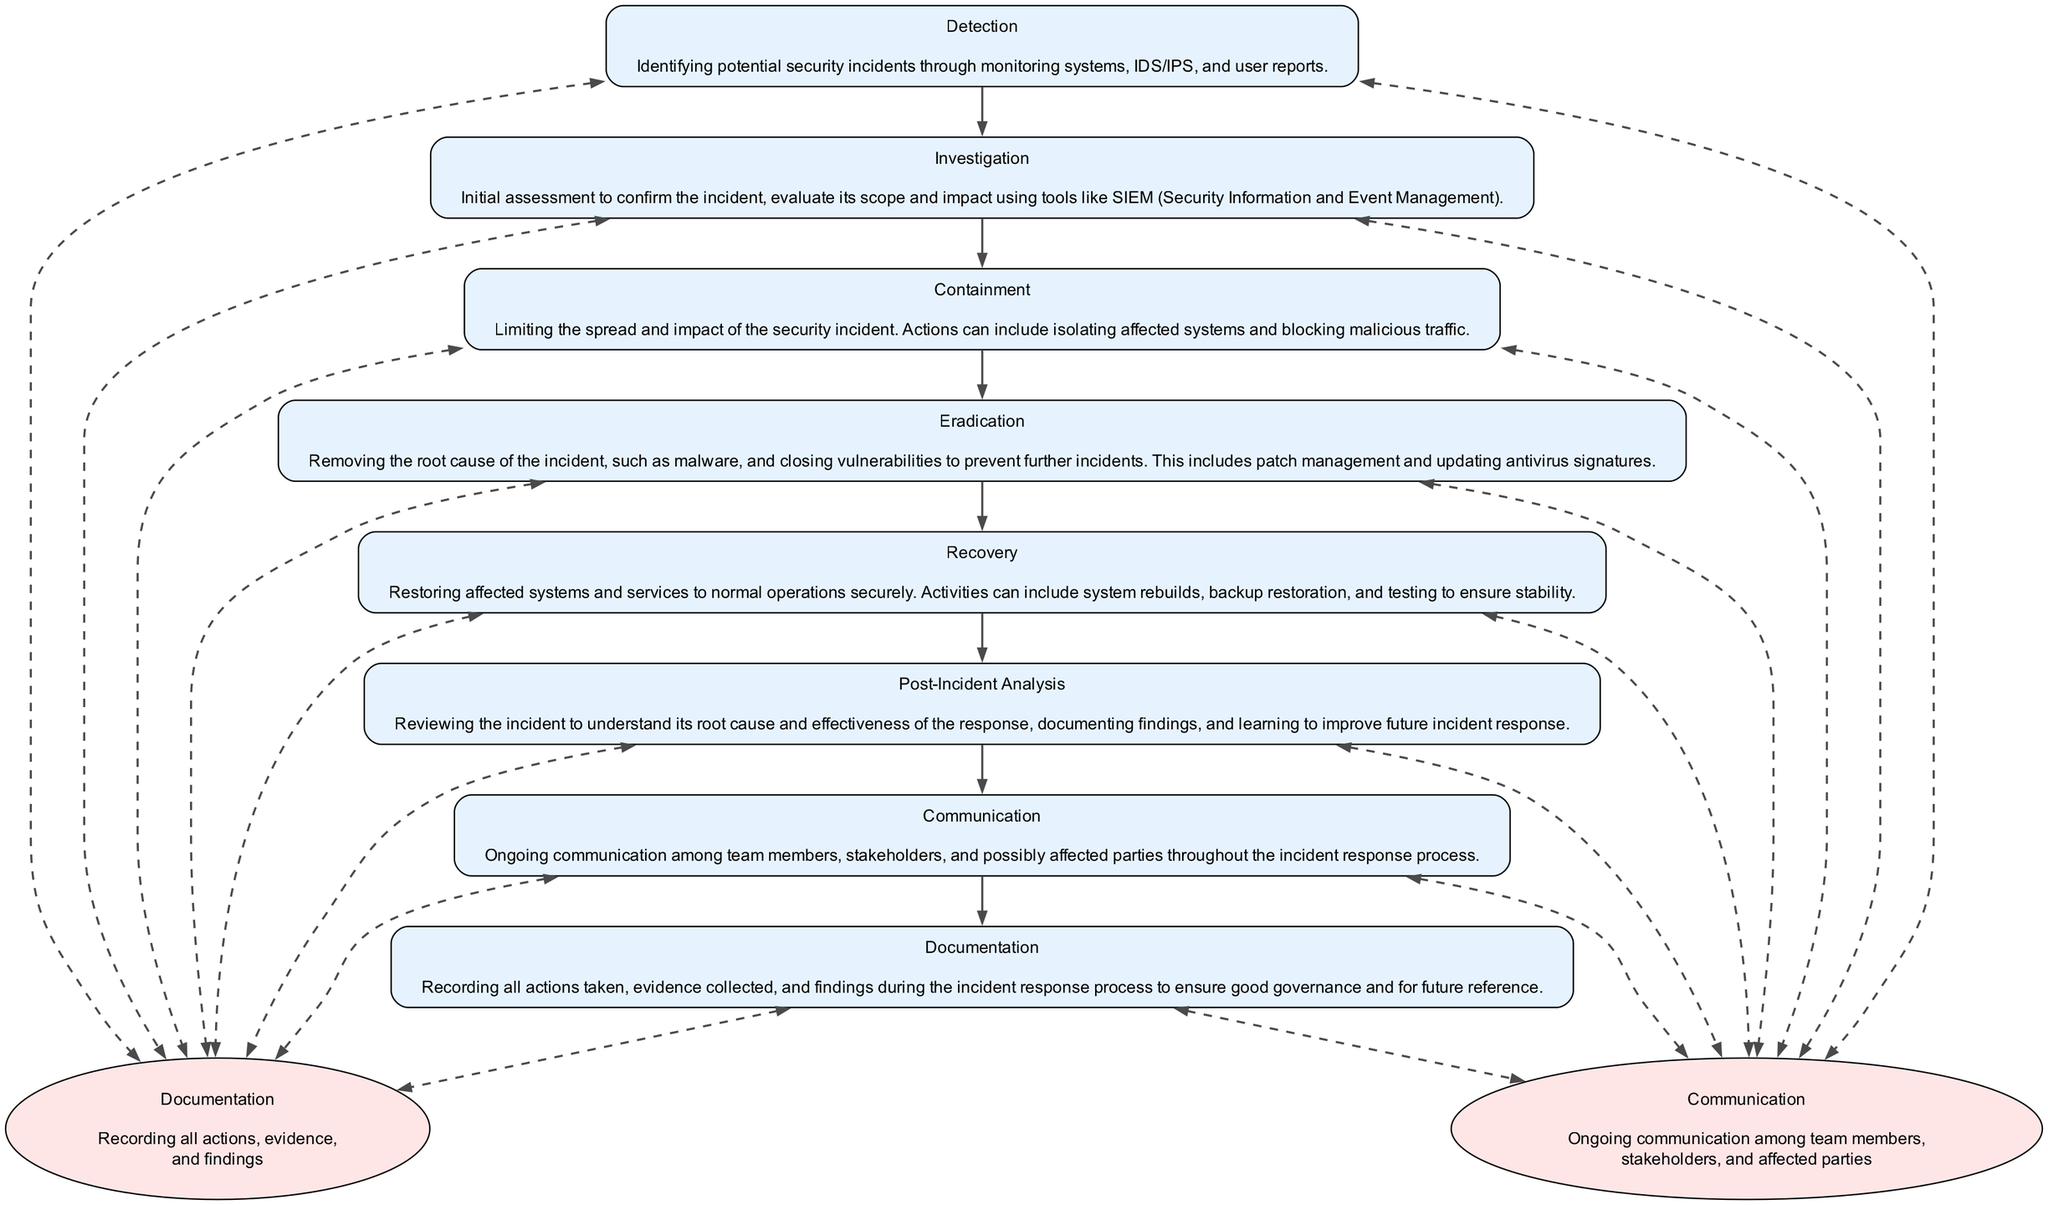What is the first step in the incident response workflow? The first step in the workflow according to the diagram is "Detection." It is the initial stage where potential security incidents are identified through monitoring and user reports.
Answer: Detection How many total nodes are present in the diagram? The total number of nodes is calculated by counting all distinct elements in the diagram, which includes the main steps and the communication and documentation nodes. In this case, there are eight distinct nodes.
Answer: Eight Which node follows "Investigation" in the workflow? The node that follows "Investigation" is "Containment." By checking the flow of the diagram, we see that after the investigation step, actions are required to contain the security incident.
Answer: Containment What type of nodes are "Communication" and "Documentation"? "Communication" and "Documentation" are both represented as ellipse-shaped nodes, which sets them apart visually from the other rectangular nodes in the diagram. Their style indicates that they are supportive processes throughout the incident response.
Answer: Ellipse What action is taken during the "Eradication" stage? During the "Eradication" stage, the primary action is to remove the root cause of the incident, which may involve the removal of malware and closing vulnerabilities. This stage is critical for preventing further incidents.
Answer: Removing malware Which two nodes are connected by dashed lines? The dashed lines connect "Communication" and "Documentation" to each of the main workflow nodes, illustrating the importance of ongoing processes throughout the incident response. This indicates that all stages involve these two elements actively.
Answer: All nodes At which stage does "Post-Incident Analysis" occur? "Post-Incident Analysis" occurs at the end of the workflow process. By examining the sequential flow of the diagram, it is clear that this stage follows "Recovery," allowing for a review of the entire incident response.
Answer: After Recovery How does the "Containment" stage affect the "Eradication" process? The "Containment" stage plays a pivotal role by limiting the spread of the incident, which makes the subsequent "Eradication" easier and more focused. This sequencing demonstrates that effective containment is necessary before eradication can effectively take place.
Answer: Limits spread What is the purpose of the "Documentation" node? The purpose of the "Documentation" node is to ensure that all actions taken, evidence collected, and findings are properly recorded during the incident response process. This is crucial for future reference and governance.
Answer: Record actions and findings 